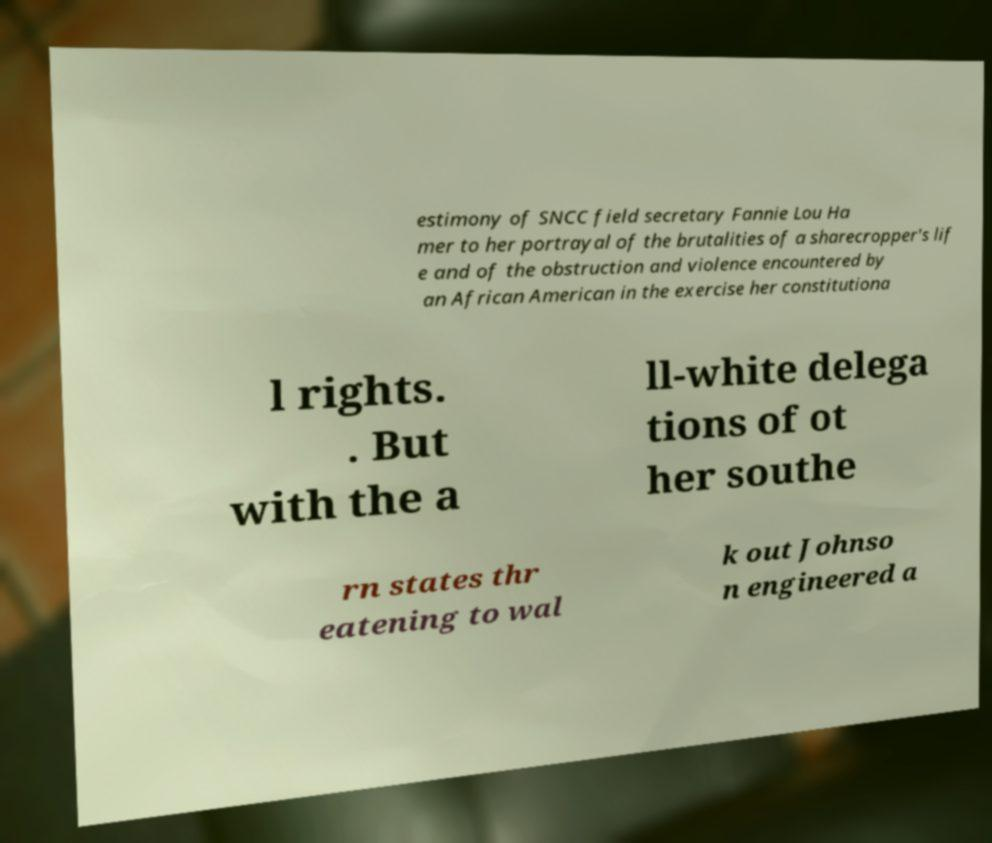Could you assist in decoding the text presented in this image and type it out clearly? estimony of SNCC field secretary Fannie Lou Ha mer to her portrayal of the brutalities of a sharecropper's lif e and of the obstruction and violence encountered by an African American in the exercise her constitutiona l rights. . But with the a ll-white delega tions of ot her southe rn states thr eatening to wal k out Johnso n engineered a 